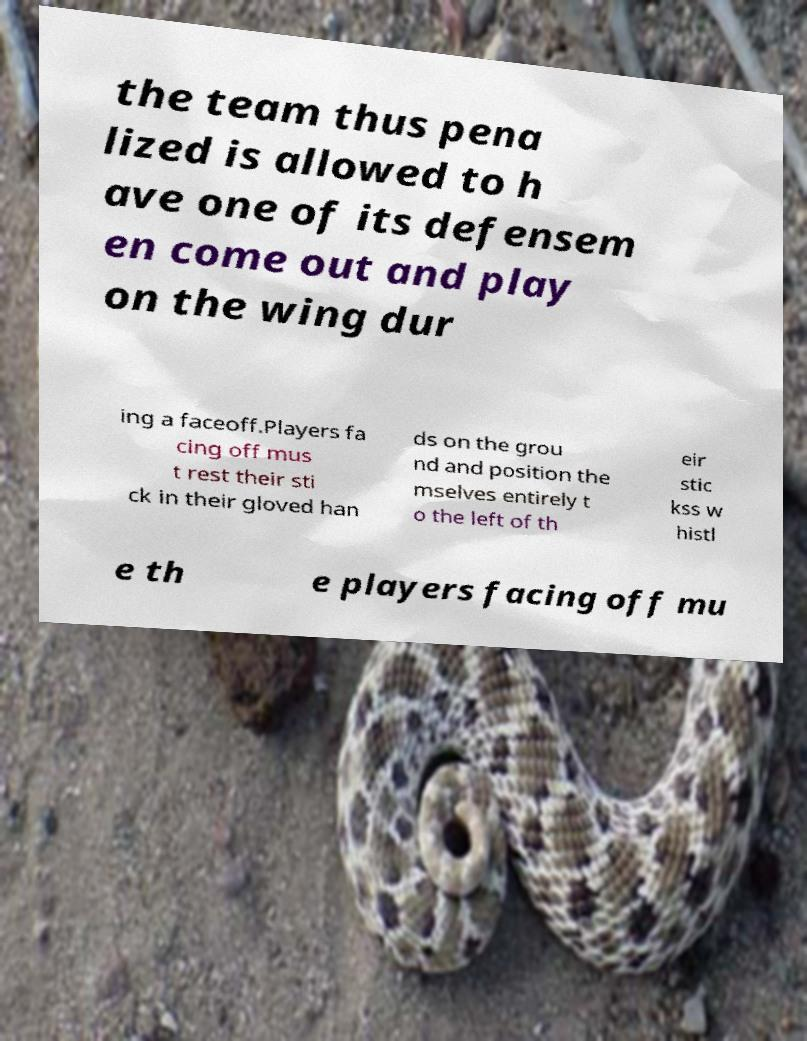What messages or text are displayed in this image? I need them in a readable, typed format. the team thus pena lized is allowed to h ave one of its defensem en come out and play on the wing dur ing a faceoff.Players fa cing off mus t rest their sti ck in their gloved han ds on the grou nd and position the mselves entirely t o the left of th eir stic kss w histl e th e players facing off mu 